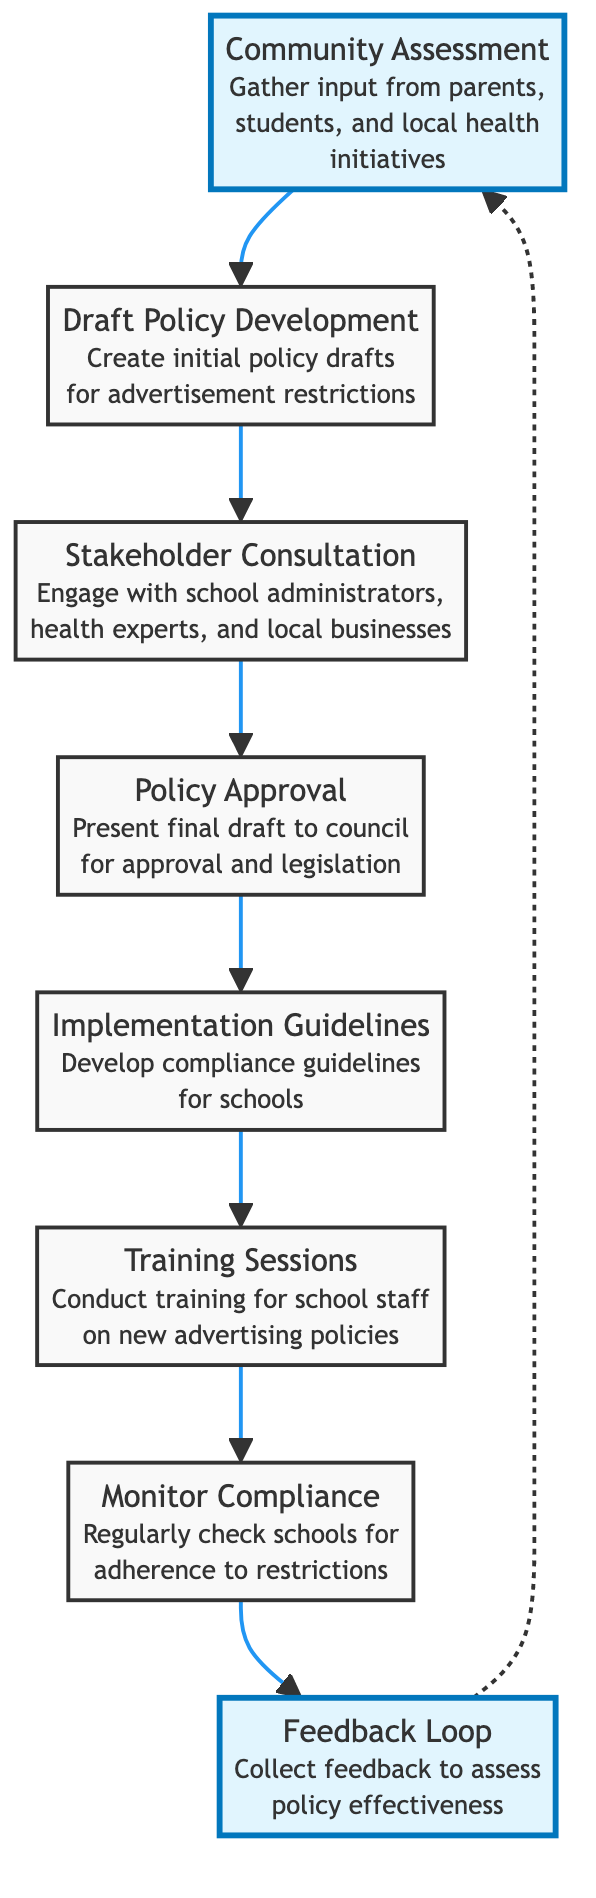What is the first step in the implementation phases? The first step in the diagram is "Community Assessment," which is the starting point of the process and indicates that input is gathered from relevant stakeholders.
Answer: Community Assessment How many nodes are present in the flow chart? By counting the distinct steps represented in the flow chart, we find that there are eight nodes, each representing a phase in the implementation of advertisement restrictions.
Answer: 8 What follows the "Draft Policy Development"? The diagram shows that "Stakeholder Consultation" follows immediately after "Draft Policy Development," indicating the next phase of engaging with relevant parties about the draft policy.
Answer: Stakeholder Consultation Which step comes after "Training Sessions"? According to the flow chart, "Monitor Compliance" is the step that immediately follows "Training Sessions," indicating the phase of regular checks for adherence to advertising restrictions.
Answer: Monitor Compliance What is the last step in the implementation phases? The last step in the flow chart is "Feedback Loop," where feedback is collected from various stakeholders to assess the effectiveness of the restrictions implemented.
Answer: Feedback Loop Is there a connection between "Feedback Loop" and "Community Assessment"? Yes, there is a dashed arrow indicating a relationship between "Feedback Loop" and "Community Assessment," signifying that feedback from the loop may lead back to community input for further assessments and improvements.
Answer: Yes How many training sessions are conducted before monitoring compliance? The flow chart indicates a direct connection from "Training Sessions" to "Monitor Compliance," which suggests that training must be completed prior to commencing compliance checks. However, the diagram does not specify a number of sessions; it simply indicates one phase directly preceding another.
Answer: 1 What type of feedback is collected in the "Feedback Loop"? The "Feedback Loop" involves collecting feedback specifically from schools, students, and parents, focusing on assessing the effectiveness of the policy implemented.
Answer: Effectiveness What is required before "Policy Approval"? The diagram indicates that "Stakeholder Consultation" is required before the "Policy Approval" phase, meaning engagement with stakeholders is necessary to refine the policy draft before it's presented for approval.
Answer: Stakeholder Consultation 